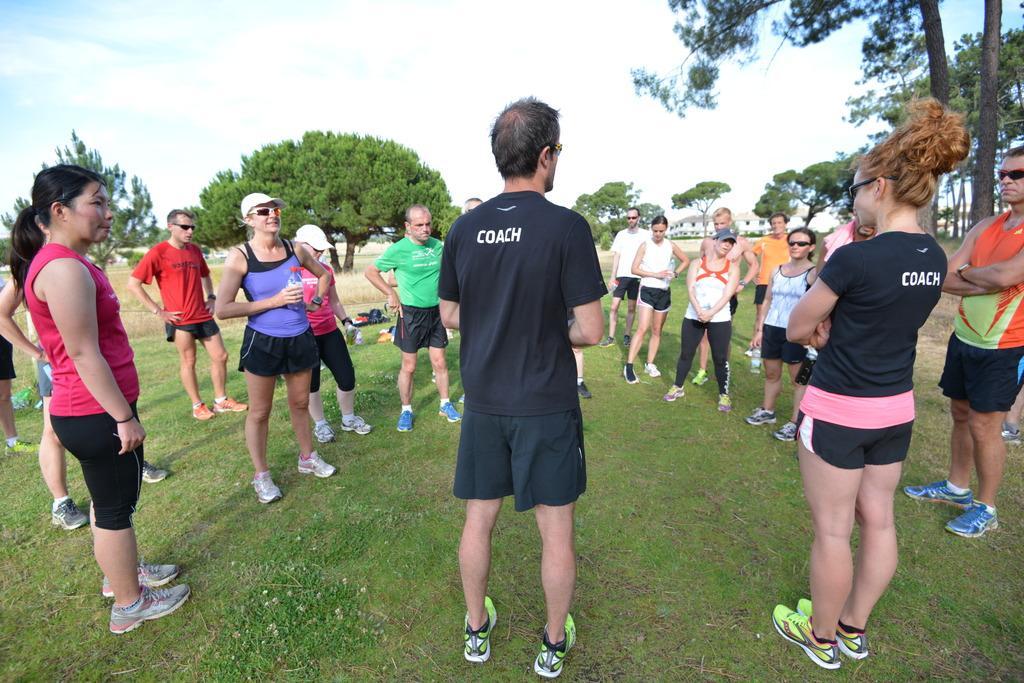Could you give a brief overview of what you see in this image? In this picture we can see a group of people standing on the grass path. Behind the people there are trees, building and a cloudy sky. 